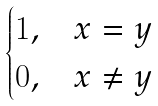Convert formula to latex. <formula><loc_0><loc_0><loc_500><loc_500>\begin{cases} 1 , & x = y \\ 0 , & x \neq y \end{cases}</formula> 